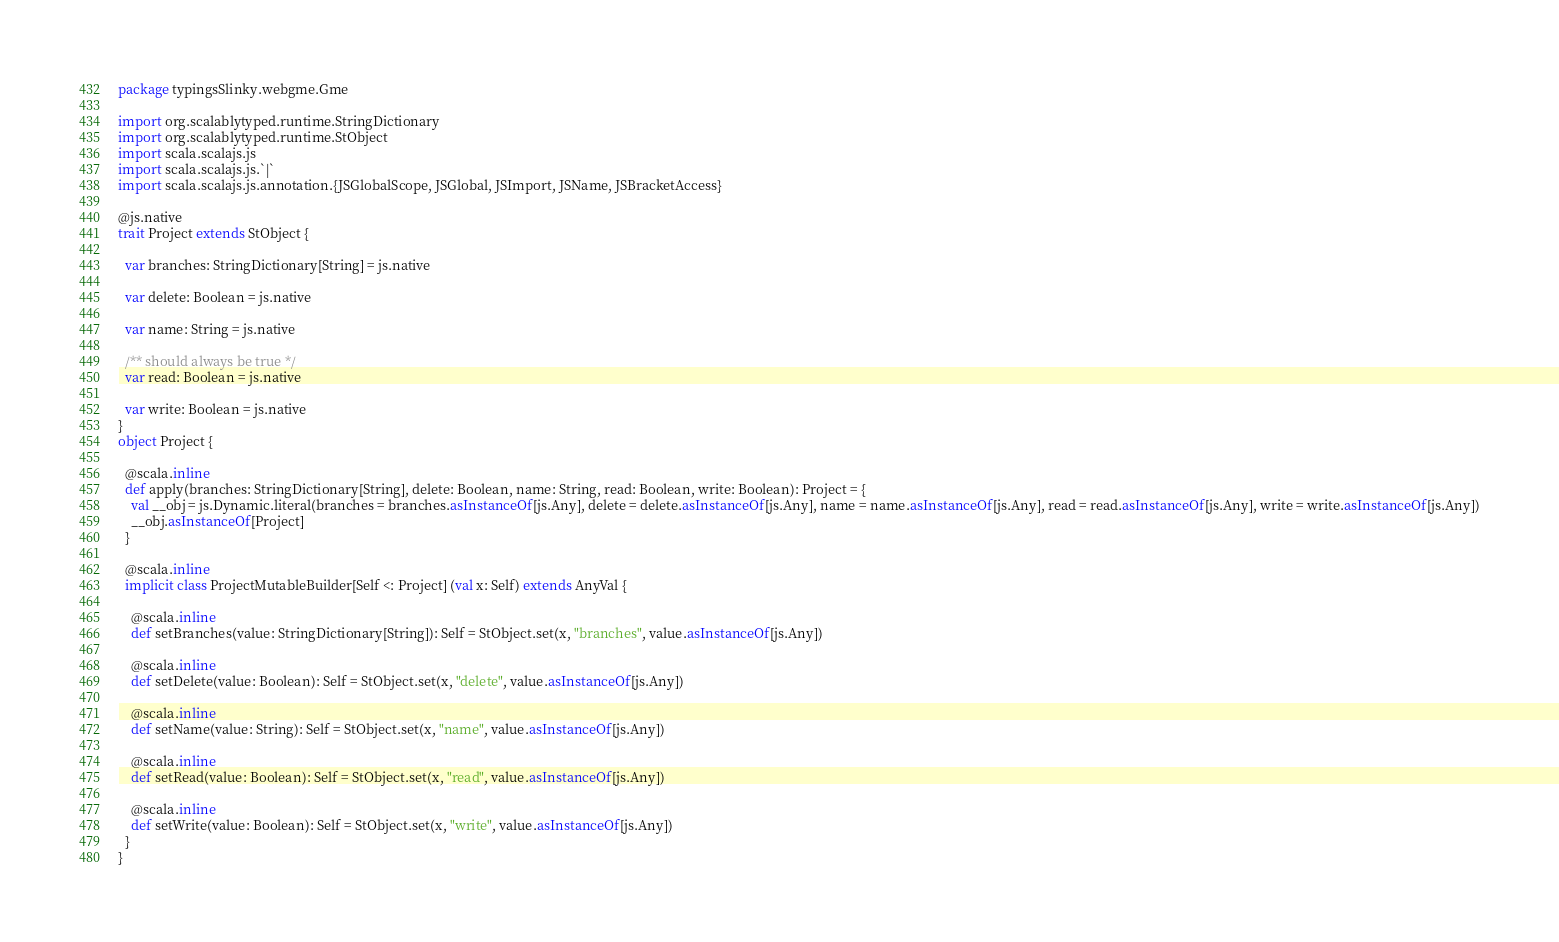Convert code to text. <code><loc_0><loc_0><loc_500><loc_500><_Scala_>package typingsSlinky.webgme.Gme

import org.scalablytyped.runtime.StringDictionary
import org.scalablytyped.runtime.StObject
import scala.scalajs.js
import scala.scalajs.js.`|`
import scala.scalajs.js.annotation.{JSGlobalScope, JSGlobal, JSImport, JSName, JSBracketAccess}

@js.native
trait Project extends StObject {
  
  var branches: StringDictionary[String] = js.native
  
  var delete: Boolean = js.native
  
  var name: String = js.native
  
  /** should always be true */
  var read: Boolean = js.native
  
  var write: Boolean = js.native
}
object Project {
  
  @scala.inline
  def apply(branches: StringDictionary[String], delete: Boolean, name: String, read: Boolean, write: Boolean): Project = {
    val __obj = js.Dynamic.literal(branches = branches.asInstanceOf[js.Any], delete = delete.asInstanceOf[js.Any], name = name.asInstanceOf[js.Any], read = read.asInstanceOf[js.Any], write = write.asInstanceOf[js.Any])
    __obj.asInstanceOf[Project]
  }
  
  @scala.inline
  implicit class ProjectMutableBuilder[Self <: Project] (val x: Self) extends AnyVal {
    
    @scala.inline
    def setBranches(value: StringDictionary[String]): Self = StObject.set(x, "branches", value.asInstanceOf[js.Any])
    
    @scala.inline
    def setDelete(value: Boolean): Self = StObject.set(x, "delete", value.asInstanceOf[js.Any])
    
    @scala.inline
    def setName(value: String): Self = StObject.set(x, "name", value.asInstanceOf[js.Any])
    
    @scala.inline
    def setRead(value: Boolean): Self = StObject.set(x, "read", value.asInstanceOf[js.Any])
    
    @scala.inline
    def setWrite(value: Boolean): Self = StObject.set(x, "write", value.asInstanceOf[js.Any])
  }
}
</code> 